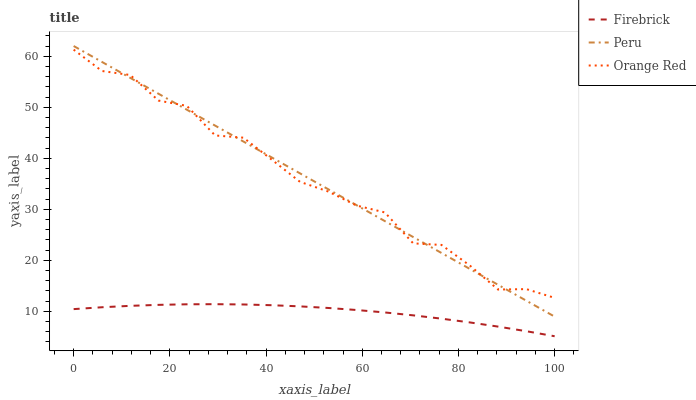Does Firebrick have the minimum area under the curve?
Answer yes or no. Yes. Does Peru have the maximum area under the curve?
Answer yes or no. Yes. Does Orange Red have the minimum area under the curve?
Answer yes or no. No. Does Orange Red have the maximum area under the curve?
Answer yes or no. No. Is Peru the smoothest?
Answer yes or no. Yes. Is Orange Red the roughest?
Answer yes or no. Yes. Is Orange Red the smoothest?
Answer yes or no. No. Is Peru the roughest?
Answer yes or no. No. Does Firebrick have the lowest value?
Answer yes or no. Yes. Does Peru have the lowest value?
Answer yes or no. No. Does Peru have the highest value?
Answer yes or no. Yes. Does Orange Red have the highest value?
Answer yes or no. No. Is Firebrick less than Peru?
Answer yes or no. Yes. Is Peru greater than Firebrick?
Answer yes or no. Yes. Does Orange Red intersect Peru?
Answer yes or no. Yes. Is Orange Red less than Peru?
Answer yes or no. No. Is Orange Red greater than Peru?
Answer yes or no. No. Does Firebrick intersect Peru?
Answer yes or no. No. 